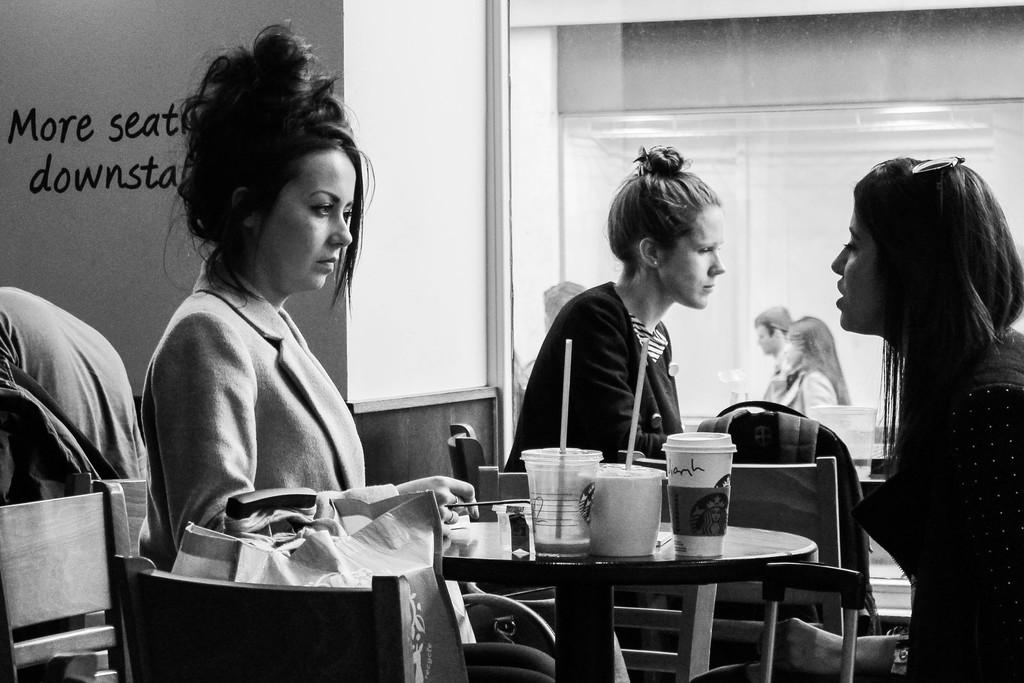How many people are in the picture? There are three people in the picture. What are the people doing in the image? The people are sitting around a table. What can be seen on the table in the image? There are glasses with straws on the table. What type of liquid is falling from the sky in the image? There is no liquid falling from the sky in the image; it only shows three people sitting around a table with glasses and straws. Are the people in the image preparing for a flight? There is no indication in the image that the people are preparing for a flight or any other specific activity. 